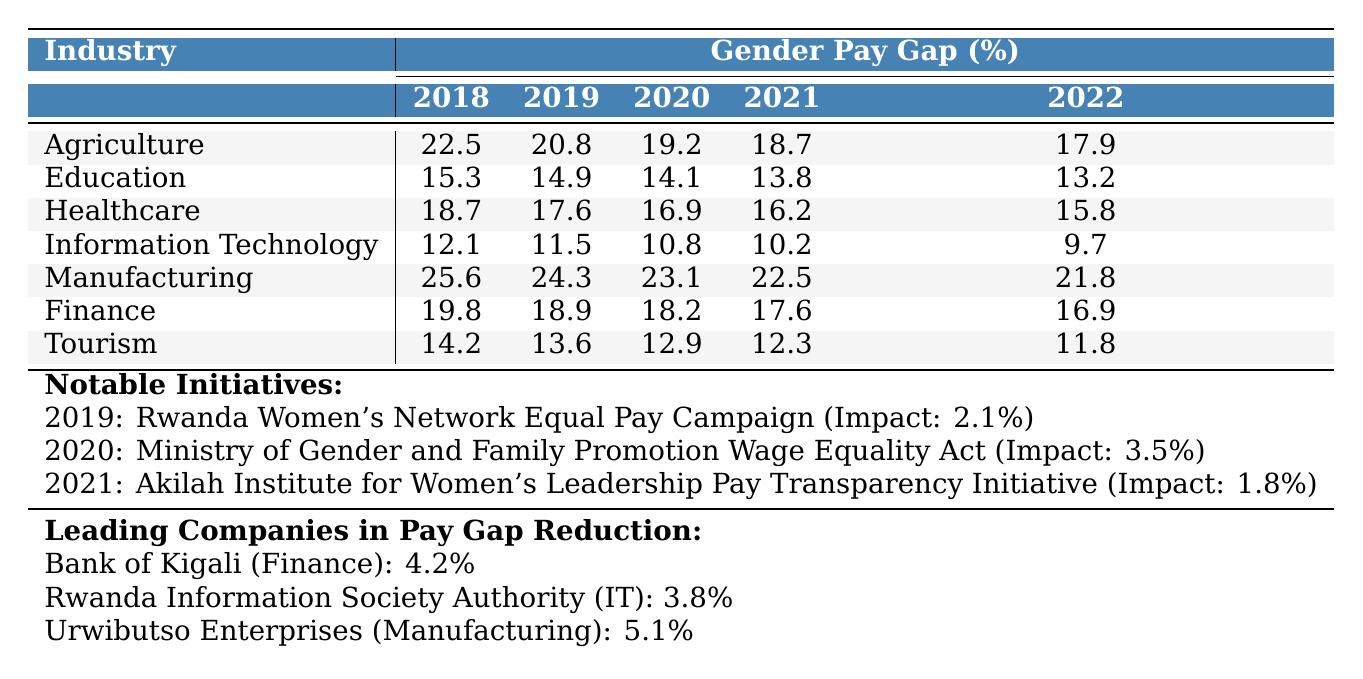What was the gender pay gap in the Information Technology industry in 2022? In the table, under the Information Technology row for the year 2022, the gender pay gap is listed as 9.7%.
Answer: 9.7% Which industry had the highest gender pay gap in 2018? By looking at the 2018 column for all industries, Manufacturing has the highest gender pay gap at 25.6%.
Answer: Manufacturing What was the percentage decrease in the gender pay gap in the Education sector from 2018 to 2022? The gender pay gap in Education decreased from 15.3% in 2018 to 13.2% in 2022, which is a decrease of 15.4%.
Answer: 15.4% What notable initiative was implemented in 2020, and what was its impact? The initiative is the "Ministry of Gender and Family Promotion Wage Equality Act", and it had an impact of 3.5%.
Answer: 3.5% True or False: The gender pay gap in Tourism was lower than in Healthcare in 2021. In 2021, the gender pay gap in Tourism was 12.3%, whereas in Healthcare it was 16.2%, so this statement is True.
Answer: True What is the average gender pay gap across all industries in 2022? To find the average, sum the gender pay gaps for each industry in 2022: (17.9 + 13.2 + 15.8 + 9.7 + 21.8 + 16.9 + 11.8) = 106.1. There are 7 industries, so the average is 106.1 / 7 = 15.2%.
Answer: 15.2% Which company in Manufacturing had the highest reduction in the gender pay gap? Urwibutso Enterprises had the highest reduction in the gender pay gap in Manufacturing, with a reduction of 5.1%.
Answer: Urwibutso Enterprises How much did the gender pay gap reduce from 2018 to 2020 in the Agriculture sector? The gender pay gap reduced from 22.5% in 2018 to 19.2% in 2020, which is a reduction of 3.3%.
Answer: 3.3% If we compare the gender pay gap in Healthcare and Finance in 2019, which is greater? For Healthcare in 2019, the pay gap was 17.6%, and for Finance, it was 18.9%. Therefore, the gender pay gap in Finance is greater.
Answer: Finance In which year did the gender pay gap in Agriculture see its lowest value? The lowest value in the Agriculture sector was 17.9%, noted in the year 2022.
Answer: 2022 Which initiative had the least impact on the gender pay gap? The initiative with the least impact is the "Akilah Institute for Women's Leadership Pay Transparency Initiative" with an impact of 1.8%.
Answer: 1.8% 